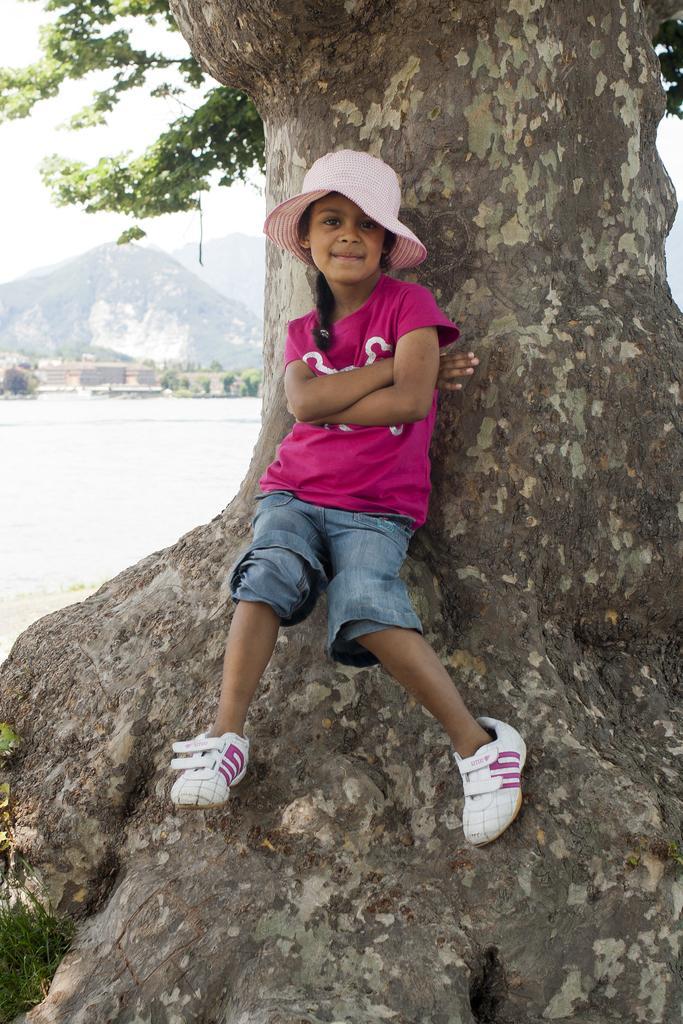Describe this image in one or two sentences. A girl is standing on the tree, this girl wore t-shirt, hat, shoes. On the left side there is water. 